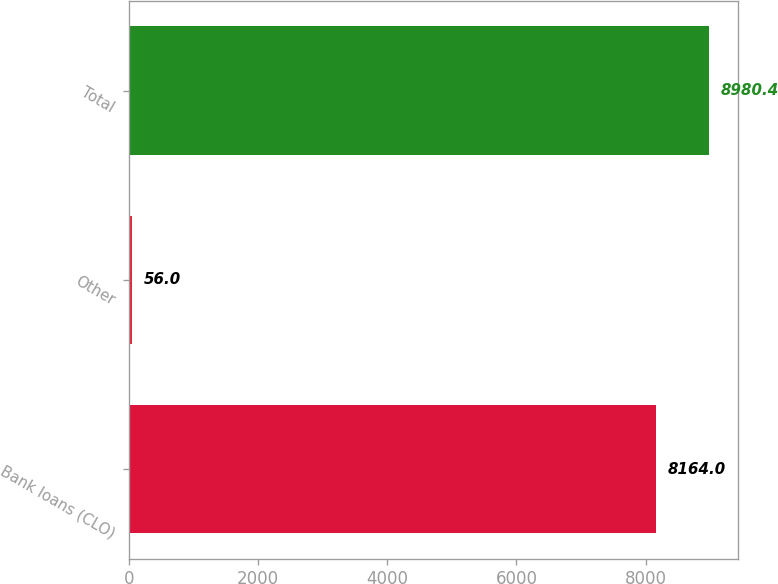Convert chart. <chart><loc_0><loc_0><loc_500><loc_500><bar_chart><fcel>Bank loans (CLO)<fcel>Other<fcel>Total<nl><fcel>8164<fcel>56<fcel>8980.4<nl></chart> 